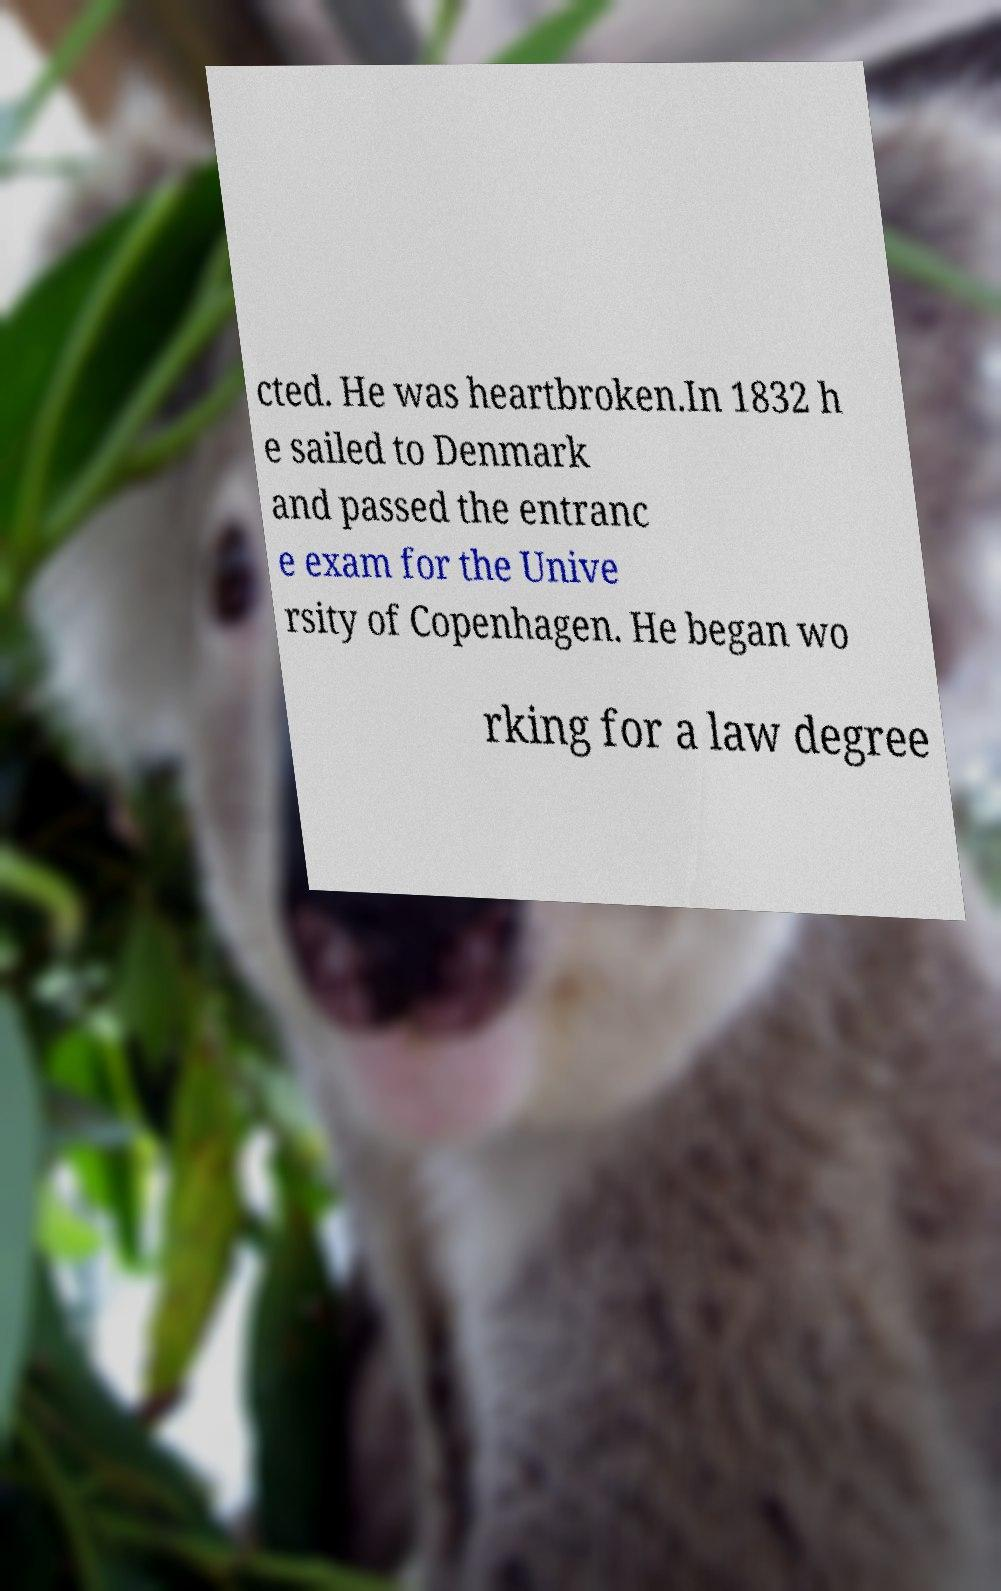Could you extract and type out the text from this image? cted. He was heartbroken.In 1832 h e sailed to Denmark and passed the entranc e exam for the Unive rsity of Copenhagen. He began wo rking for a law degree 